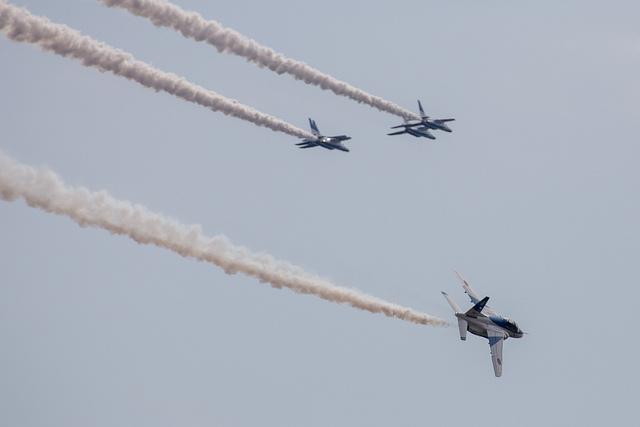Are the propeller planes?
Concise answer only. No. What type of plane is this?
Quick response, please. Jet. Are the planes jet fighters?
Concise answer only. Yes. How many planes are in the picture?
Give a very brief answer. 4. What is trailing behind each plane?
Give a very brief answer. Smoke. 